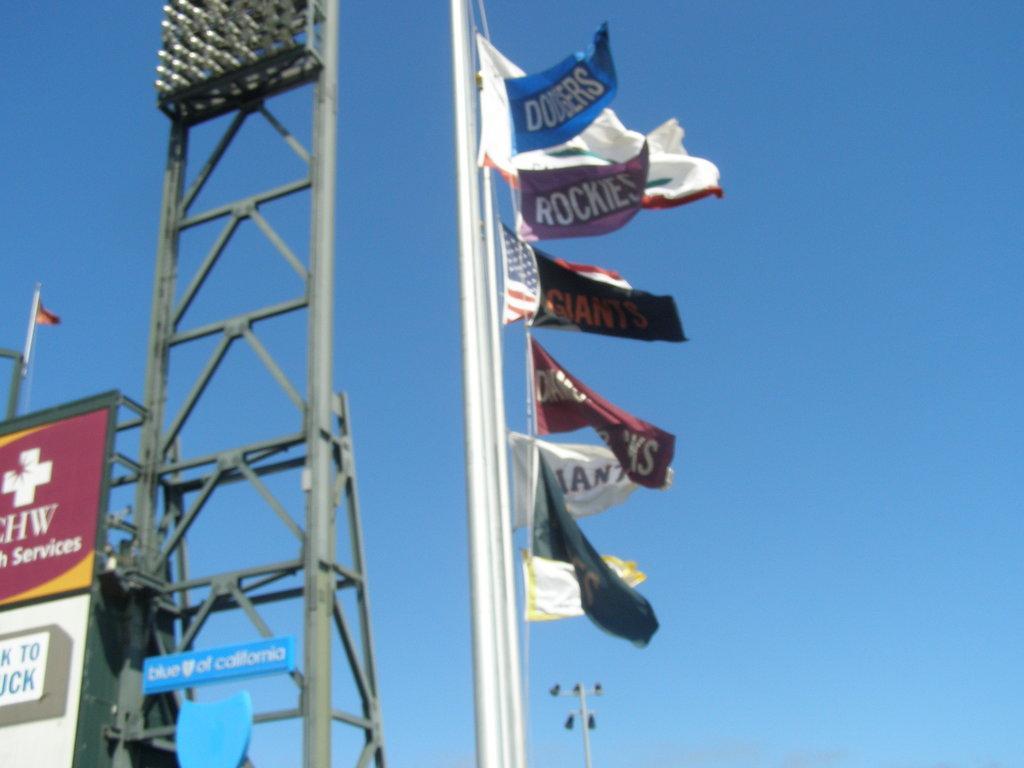Could you give a brief overview of what you see in this image? In this image there are boards with some text written on it and there is a light stand and there is a pole and on the pole there are flags. In the background there is an object which is white in colour and at the top we can see sky. 